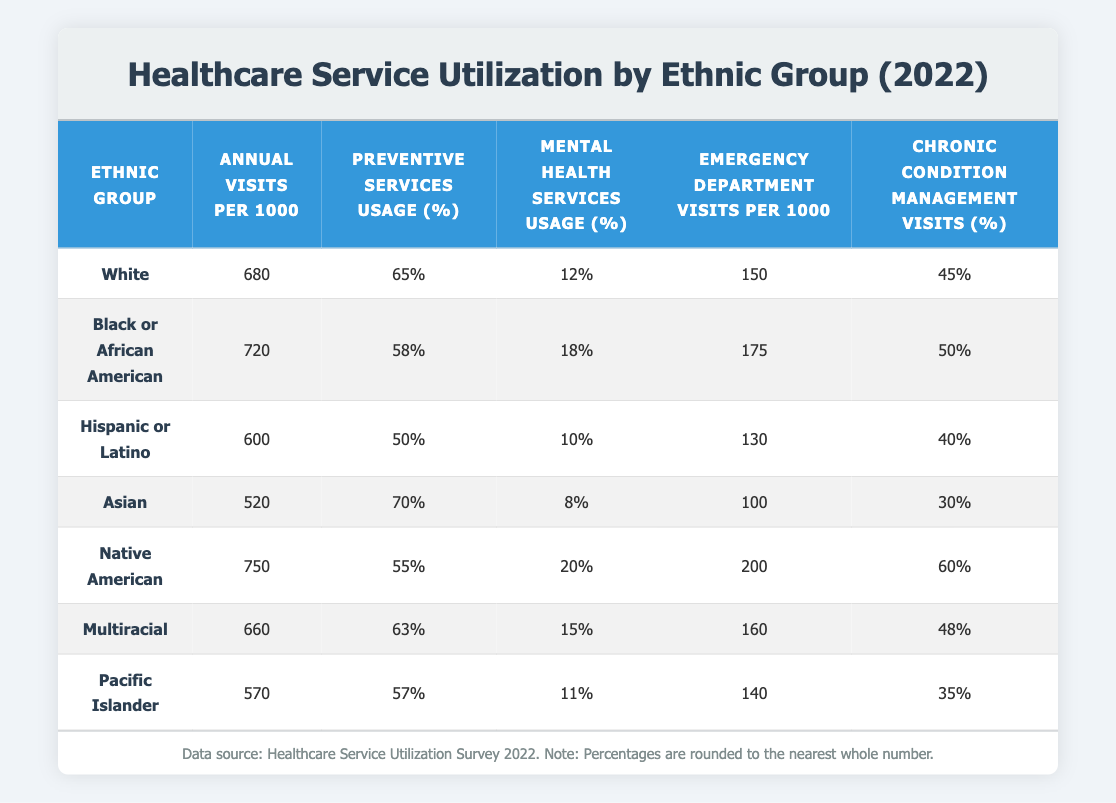What is the annual visit rate per 1000 for the Black or African American group? According to the table, the annual visits per 1000 for the Black or African American group is listed directly under that ethnic group. Referring to the table, I find that it is 720.
Answer: 720 Which ethnic group has the highest usage of mental health services? By examining the mental health services usage column in the table, I compare the usage percentages of all ethnic groups. The highest percentage is 20% for the Native American group.
Answer: Native American What is the difference in emergency department visits per 1000 between Asian and Pacific Islander groups? To find this difference, I look at the emergency department visits per 1000 for both groups: Asian has 100 visits per 1000, and Pacific Islander has 140 visits per 1000. The difference is calculated as 140 - 100 = 40.
Answer: 40 True or False: The Hispanic or Latino group has a higher percentage of preventive services usage than the Black or African American group. Checking the table, the preventive services usage for Hispanic or Latino is 50%, while for Black or African American it is 58%. Thus, the statement is false as 50% is lower than 58%.
Answer: False What is the average annual visits per 1000 for the Multiracial and Hispanic or Latino groups combined? First, I find the annual visits per 1000 for both ethnic groups: Multiracial is 660 and Hispanic or Latino is 600. I sum these values: 660 + 600 = 1260. I then divide the total by 2 (since there are two groups) to get the average: 1260 / 2 = 630.
Answer: 630 Which ethnic group has the lowest annual visits per 1000, and what is that number? Looking at the annual visits per 1000 column, I identify the group with the lowest number. The Asian group has the fewest visits at 520 per 1000.
Answer: Asian: 520 How many more chronic condition management visits are there for the Native American group compared to the White group? From the table, I see that Native American has 60% for chronic condition management visits and White has 45%. To find the difference, I subtract 45 from 60, resulting in a difference of 15%.
Answer: 15% Is the preventive services usage for the White group above or below 60%? Referring to the preventive services usage for the White group, which is listed as 65%. Since 65% is above 60%, the answer is yes.
Answer: Yes 